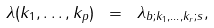<formula> <loc_0><loc_0><loc_500><loc_500>\lambda ( k _ { 1 } , \dots , k _ { p } ) \ = \ \lambda _ { b ; k _ { 1 } , \dots , k _ { r } ; s } ,</formula> 